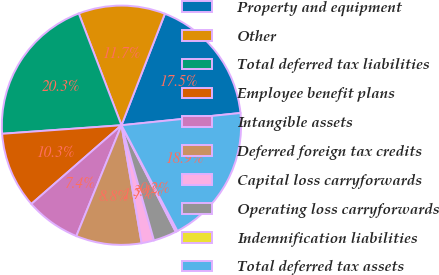Convert chart to OTSL. <chart><loc_0><loc_0><loc_500><loc_500><pie_chart><fcel>Property and equipment<fcel>Other<fcel>Total deferred tax liabilities<fcel>Employee benefit plans<fcel>Intangible assets<fcel>Deferred foreign tax credits<fcel>Capital loss carryforwards<fcel>Operating loss carryforwards<fcel>Indemnification liabilities<fcel>Total deferred tax assets<nl><fcel>17.46%<fcel>11.72%<fcel>20.33%<fcel>10.29%<fcel>7.42%<fcel>8.85%<fcel>1.68%<fcel>3.12%<fcel>0.25%<fcel>18.89%<nl></chart> 